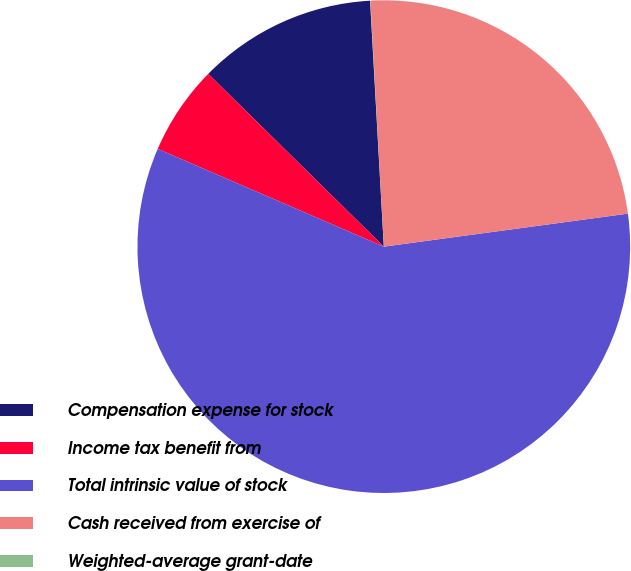Convert chart. <chart><loc_0><loc_0><loc_500><loc_500><pie_chart><fcel>Compensation expense for stock<fcel>Income tax benefit from<fcel>Total intrinsic value of stock<fcel>Cash received from exercise of<fcel>Weighted-average grant-date<nl><fcel>11.74%<fcel>5.88%<fcel>58.64%<fcel>23.73%<fcel>0.02%<nl></chart> 